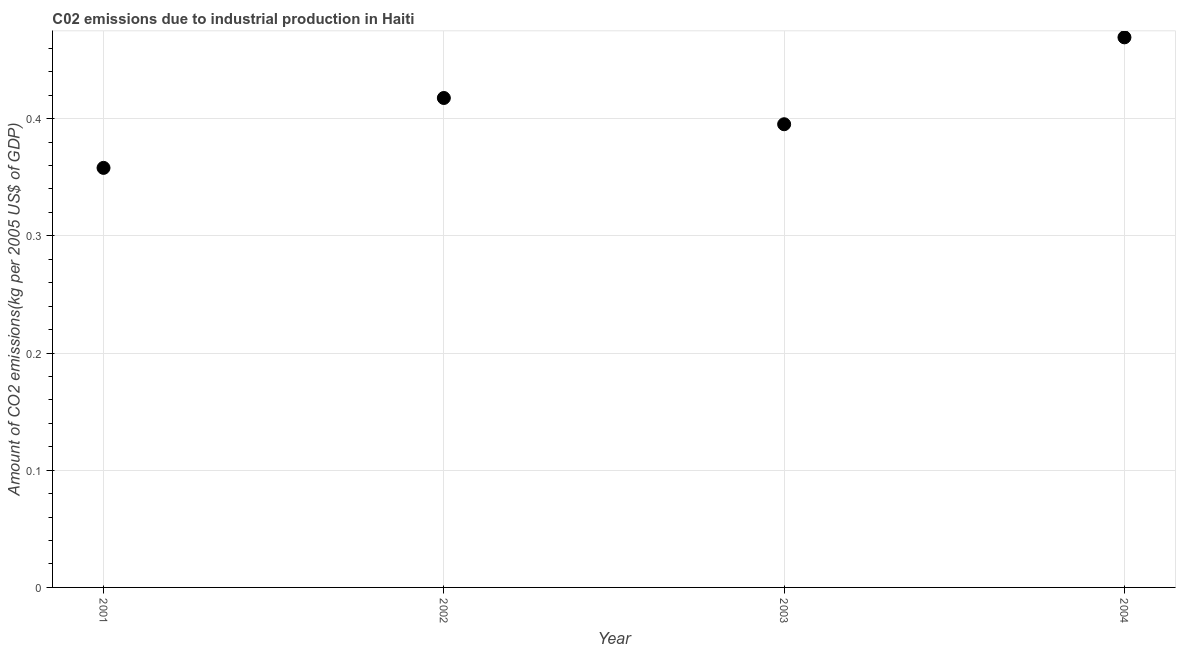What is the amount of co2 emissions in 2003?
Offer a terse response. 0.4. Across all years, what is the maximum amount of co2 emissions?
Ensure brevity in your answer.  0.47. Across all years, what is the minimum amount of co2 emissions?
Offer a very short reply. 0.36. In which year was the amount of co2 emissions maximum?
Provide a succinct answer. 2004. In which year was the amount of co2 emissions minimum?
Offer a terse response. 2001. What is the sum of the amount of co2 emissions?
Your answer should be compact. 1.64. What is the difference between the amount of co2 emissions in 2001 and 2004?
Your answer should be compact. -0.11. What is the average amount of co2 emissions per year?
Your answer should be compact. 0.41. What is the median amount of co2 emissions?
Give a very brief answer. 0.41. In how many years, is the amount of co2 emissions greater than 0.22 kg per 2005 US$ of GDP?
Give a very brief answer. 4. Do a majority of the years between 2003 and 2001 (inclusive) have amount of co2 emissions greater than 0.42000000000000004 kg per 2005 US$ of GDP?
Your response must be concise. No. What is the ratio of the amount of co2 emissions in 2001 to that in 2003?
Your response must be concise. 0.91. Is the amount of co2 emissions in 2002 less than that in 2003?
Your answer should be compact. No. Is the difference between the amount of co2 emissions in 2001 and 2002 greater than the difference between any two years?
Your answer should be compact. No. What is the difference between the highest and the second highest amount of co2 emissions?
Offer a very short reply. 0.05. Is the sum of the amount of co2 emissions in 2002 and 2004 greater than the maximum amount of co2 emissions across all years?
Your answer should be very brief. Yes. What is the difference between the highest and the lowest amount of co2 emissions?
Your answer should be very brief. 0.11. How many dotlines are there?
Your answer should be compact. 1. What is the difference between two consecutive major ticks on the Y-axis?
Keep it short and to the point. 0.1. Are the values on the major ticks of Y-axis written in scientific E-notation?
Make the answer very short. No. Does the graph contain any zero values?
Offer a very short reply. No. What is the title of the graph?
Offer a terse response. C02 emissions due to industrial production in Haiti. What is the label or title of the Y-axis?
Your answer should be compact. Amount of CO2 emissions(kg per 2005 US$ of GDP). What is the Amount of CO2 emissions(kg per 2005 US$ of GDP) in 2001?
Your response must be concise. 0.36. What is the Amount of CO2 emissions(kg per 2005 US$ of GDP) in 2002?
Provide a succinct answer. 0.42. What is the Amount of CO2 emissions(kg per 2005 US$ of GDP) in 2003?
Keep it short and to the point. 0.4. What is the Amount of CO2 emissions(kg per 2005 US$ of GDP) in 2004?
Give a very brief answer. 0.47. What is the difference between the Amount of CO2 emissions(kg per 2005 US$ of GDP) in 2001 and 2002?
Your answer should be very brief. -0.06. What is the difference between the Amount of CO2 emissions(kg per 2005 US$ of GDP) in 2001 and 2003?
Keep it short and to the point. -0.04. What is the difference between the Amount of CO2 emissions(kg per 2005 US$ of GDP) in 2001 and 2004?
Provide a succinct answer. -0.11. What is the difference between the Amount of CO2 emissions(kg per 2005 US$ of GDP) in 2002 and 2003?
Give a very brief answer. 0.02. What is the difference between the Amount of CO2 emissions(kg per 2005 US$ of GDP) in 2002 and 2004?
Offer a terse response. -0.05. What is the difference between the Amount of CO2 emissions(kg per 2005 US$ of GDP) in 2003 and 2004?
Give a very brief answer. -0.07. What is the ratio of the Amount of CO2 emissions(kg per 2005 US$ of GDP) in 2001 to that in 2002?
Your answer should be compact. 0.86. What is the ratio of the Amount of CO2 emissions(kg per 2005 US$ of GDP) in 2001 to that in 2003?
Ensure brevity in your answer.  0.91. What is the ratio of the Amount of CO2 emissions(kg per 2005 US$ of GDP) in 2001 to that in 2004?
Give a very brief answer. 0.76. What is the ratio of the Amount of CO2 emissions(kg per 2005 US$ of GDP) in 2002 to that in 2003?
Make the answer very short. 1.06. What is the ratio of the Amount of CO2 emissions(kg per 2005 US$ of GDP) in 2002 to that in 2004?
Provide a short and direct response. 0.89. What is the ratio of the Amount of CO2 emissions(kg per 2005 US$ of GDP) in 2003 to that in 2004?
Your response must be concise. 0.84. 